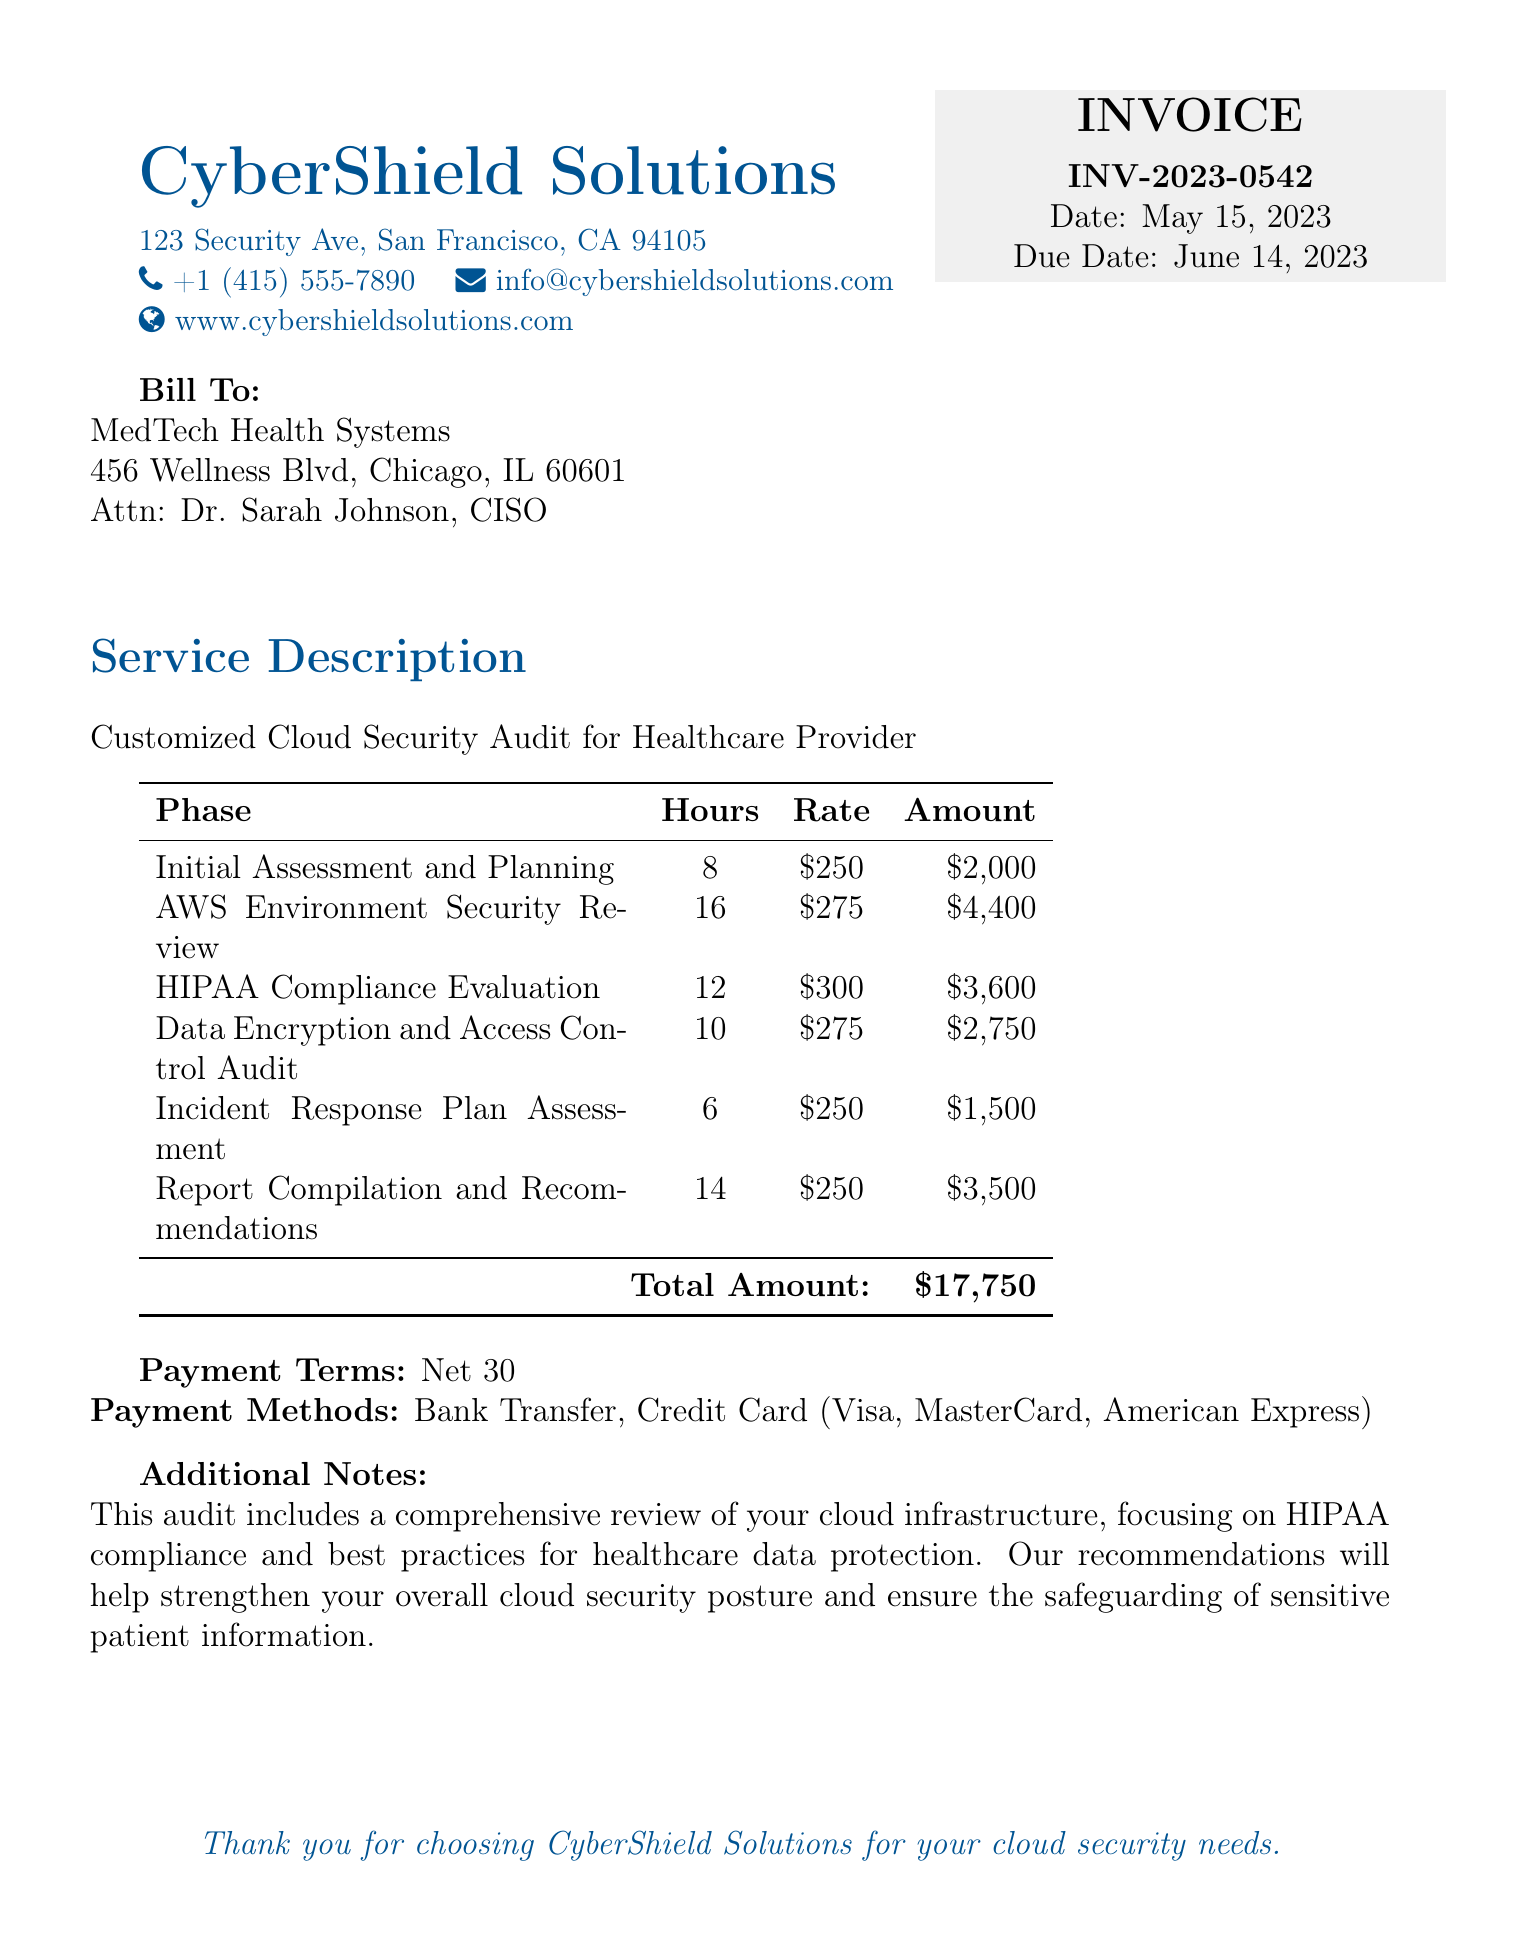What is the invoice number? The invoice number is clearly stated in the document as INV-2023-0542.
Answer: INV-2023-0542 What is the total amount due? The total amount due is listed in the table under the total, which is $17,750.
Answer: $17,750 Who is the billable recipient? The recipient's name and details are provided in the "Bill To" section as MedTech Health Systems.
Answer: MedTech Health Systems How many hours were spent on the AWS Environment Security Review? The document specifies that 16 hours were allocated for the AWS Environment Security Review phase.
Answer: 16 What is the rate for HIPAA Compliance Evaluation? The rate for HIPAA Compliance Evaluation is noted as $300 in the document.
Answer: $300 What is the payment term? Payment terms are listed as Net 30, indicating payment is due within 30 days.
Answer: Net 30 Which method of payment is NOT mentioned in the document? The document mentions Bank Transfer, Credit Card (Visa, MasterCard, American Express) but does not mention cash.
Answer: Cash What phase took the least amount of hours? The Incident Response Plan Assessment phase took the least time, with only 6 hours spent.
Answer: 6 What is included in the additional notes? The additional notes mention that the audit includes a comprehensive review of cloud infrastructure, focusing on HIPAA compliance and best practices.
Answer: Comprehensive review of cloud infrastructure 